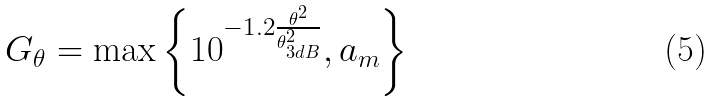Convert formula to latex. <formula><loc_0><loc_0><loc_500><loc_500>{ G _ { \theta } } = \max \left \{ { { { 1 0 } ^ { - 1 . 2 \frac { \theta ^ { 2 } } { { \theta _ { 3 d B } ^ { 2 } } } } } , { a _ { m } } } \right \}</formula> 